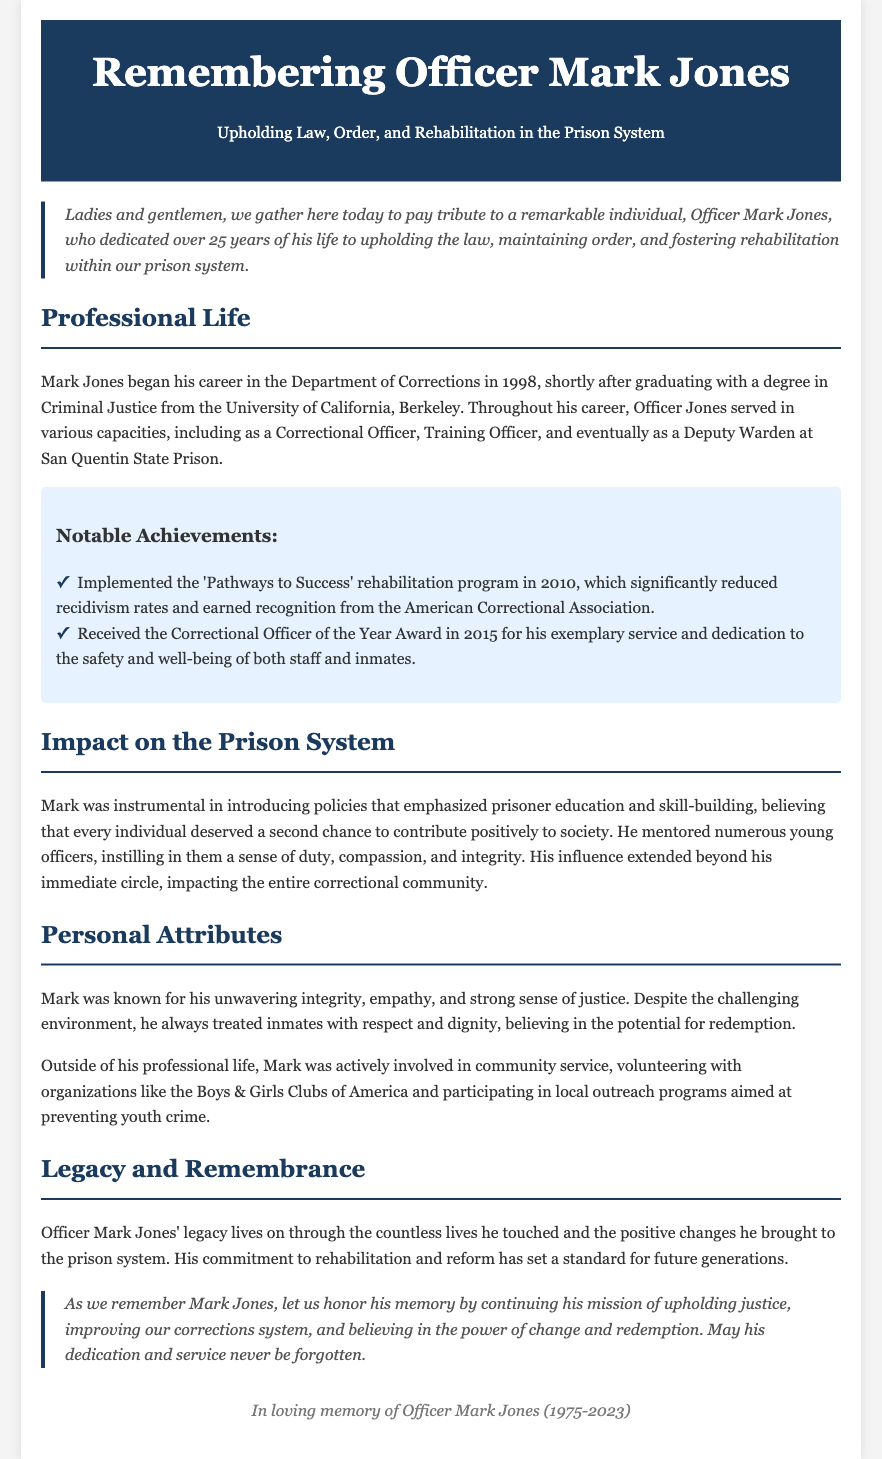What year did Officer Mark Jones begin his career? Officer Mark Jones began his career in the Department of Corrections in 1998, which is explicitly mentioned in the document.
Answer: 1998 What degree did Mark Jones earn? The document states that Mark graduated with a degree in Criminal Justice from the University of California, Berkeley.
Answer: Criminal Justice In what year was the 'Pathways to Success' rehabilitation program implemented? The implementation year of the 'Pathways to Success' rehabilitation program is outlined in the document as 2010.
Answer: 2010 How many years did Officer Mark Jones serve in the prison system? The document mentions that he dedicated over 25 years to his service, thus the total duration can be directly referenced from this detail.
Answer: 25 years Which award did Mark Jones receive in 2015? The document notes that he received the Correctional Officer of the Year Award in 2015, which is a specific recognition named in the text.
Answer: Correctional Officer of the Year Award What personal quality did Mark Jones demonstrate towards inmates? The document details that he treated inmates with respect and dignity, which highlights a key personal attribute of his character.
Answer: Respect and dignity Which organization did Mark volunteer with? The document mentions that he volunteered with the Boys & Girls Clubs of America, pointing out his community service involvement.
Answer: Boys & Girls Clubs of America What impact did Officer Mark Jones have on young officers? The document indicates that he mentored numerous young officers, instilling them with a sense of duty, compassion, and integrity.
Answer: Mentoring young officers What was Mark Jones's belief about individuals in prison? The document states that he believed every individual deserved a second chance to contribute positively to society, conveying a core aspect of his philosophy.
Answer: Second chance 